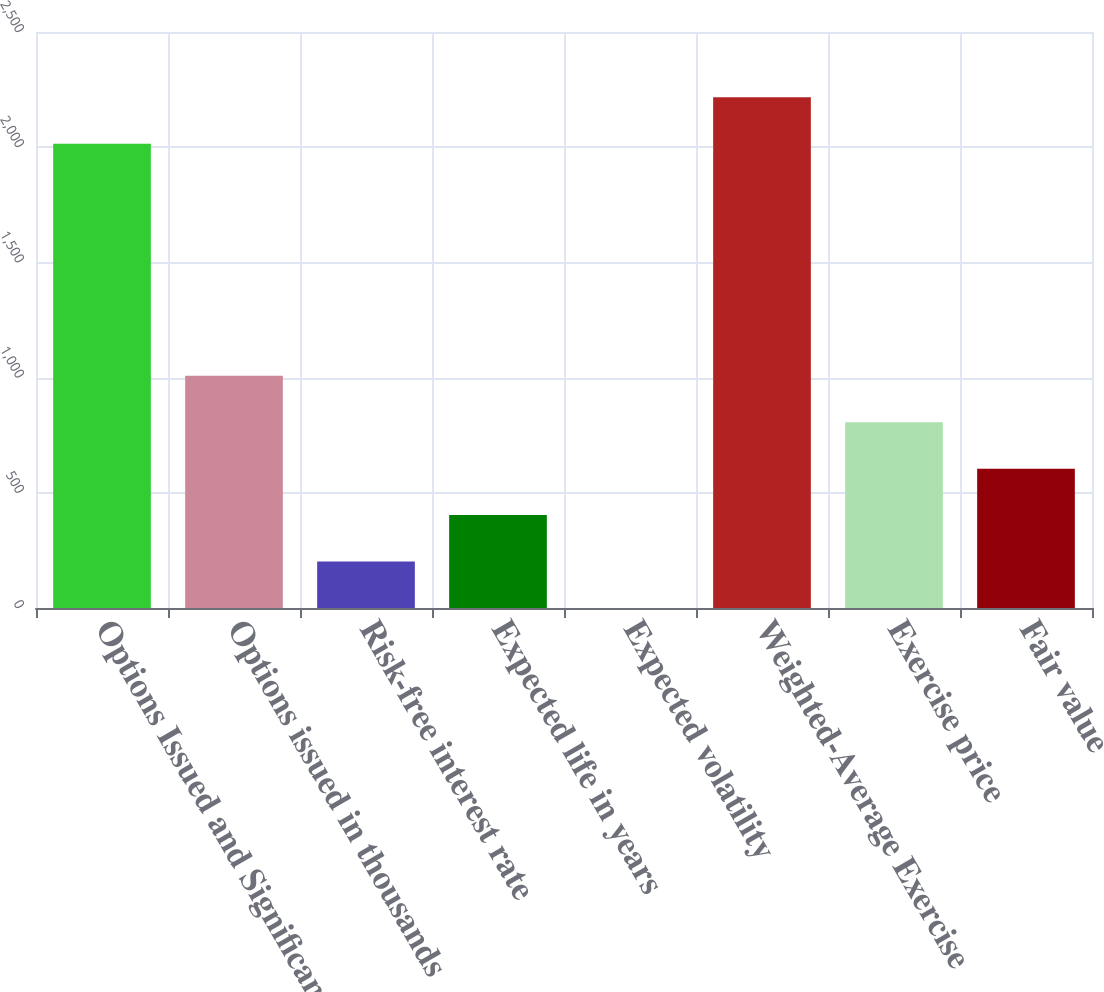Convert chart. <chart><loc_0><loc_0><loc_500><loc_500><bar_chart><fcel>Options Issued and Significant<fcel>Options issued in thousands<fcel>Risk-free interest rate<fcel>Expected life in years<fcel>Expected volatility<fcel>Weighted-Average Exercise<fcel>Exercise price<fcel>Fair value<nl><fcel>2015<fcel>1007.61<fcel>201.73<fcel>403.2<fcel>0.26<fcel>2216.47<fcel>806.14<fcel>604.67<nl></chart> 